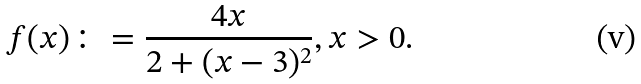<formula> <loc_0><loc_0><loc_500><loc_500>f ( x ) \colon = \frac { 4 x } { 2 + ( x - 3 ) ^ { 2 } } , x > 0 .</formula> 